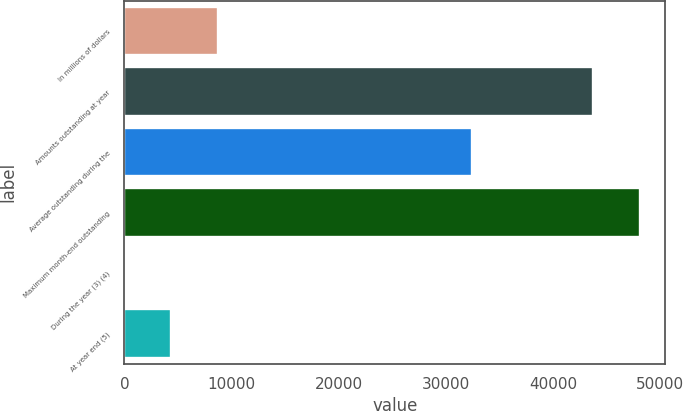Convert chart. <chart><loc_0><loc_0><loc_500><loc_500><bar_chart><fcel>In millions of dollars<fcel>Amounts outstanding at year<fcel>Average outstanding during the<fcel>Maximum month-end outstanding<fcel>During the year (3) (4)<fcel>At year end (5)<nl><fcel>8742.96<fcel>43695<fcel>32468<fcel>48064<fcel>4.96<fcel>4373.96<nl></chart> 